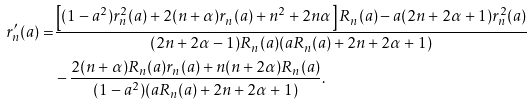<formula> <loc_0><loc_0><loc_500><loc_500>r _ { n } ^ { \prime } ( a ) = & \frac { \left [ ( 1 - a ^ { 2 } ) r _ { n } ^ { 2 } ( a ) + 2 ( n + \alpha ) r _ { n } ( a ) + n ^ { 2 } + 2 n \alpha \right ] R _ { n } ( a ) - a ( 2 n + 2 \alpha + 1 ) r ^ { 2 } _ { n } ( a ) } { ( 2 n + 2 \alpha - 1 ) R _ { n } ( a ) ( a R _ { n } ( a ) + 2 n + 2 \alpha + 1 ) } \\ & - \frac { 2 ( n + \alpha ) R _ { n } ( a ) r _ { n } ( a ) + n ( n + 2 \alpha ) R _ { n } ( a ) } { ( 1 - a ^ { 2 } ) ( a R _ { n } ( a ) + 2 n + 2 \alpha + 1 ) } .</formula> 